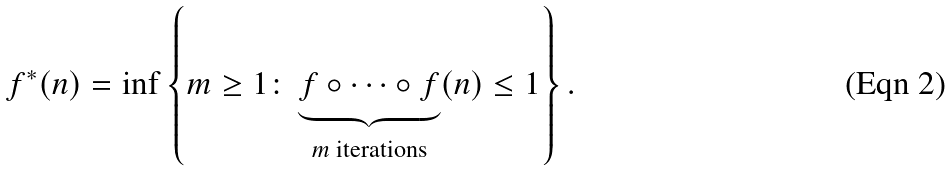Convert formula to latex. <formula><loc_0><loc_0><loc_500><loc_500>f ^ { * } ( n ) = \inf \left \{ m \geq 1 \colon \underbrace { f \circ \dots \circ f } _ { m \text {     iterations} } ( n ) \leq 1 \right \} .</formula> 